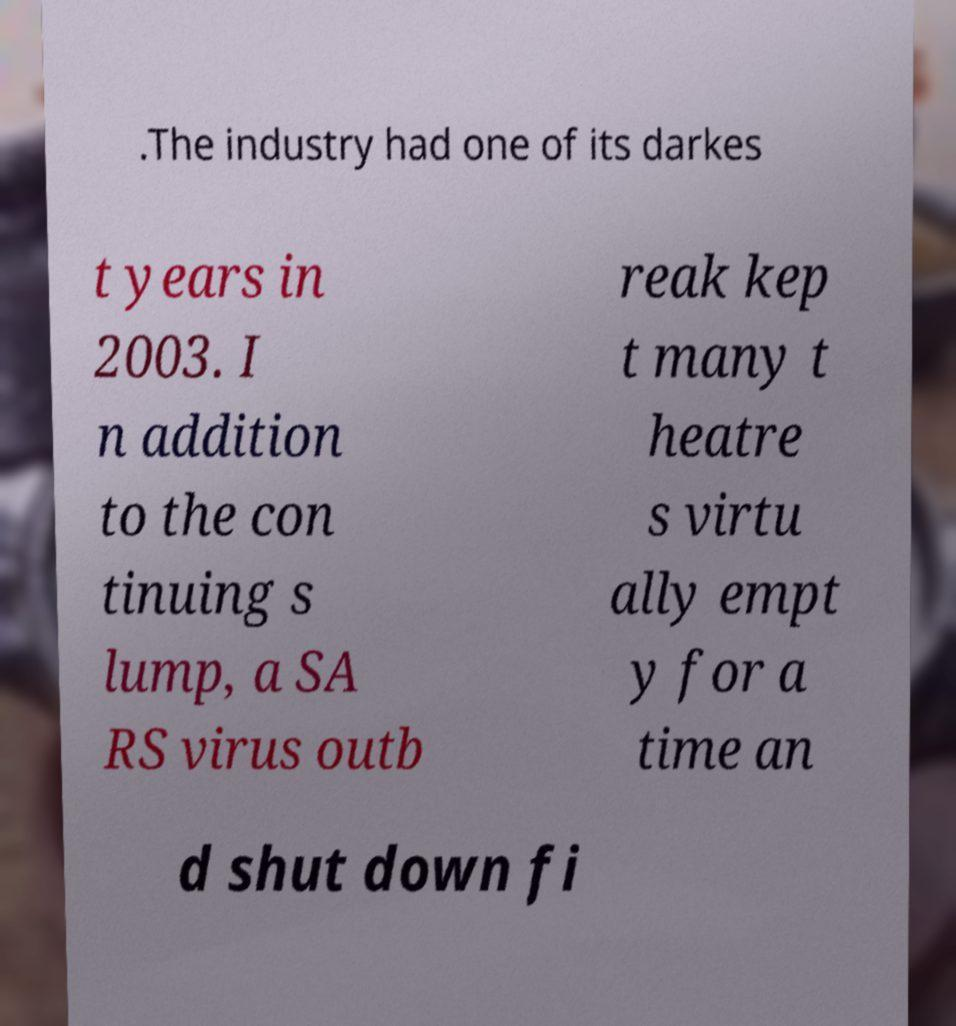Please read and relay the text visible in this image. What does it say? .The industry had one of its darkes t years in 2003. I n addition to the con tinuing s lump, a SA RS virus outb reak kep t many t heatre s virtu ally empt y for a time an d shut down fi 